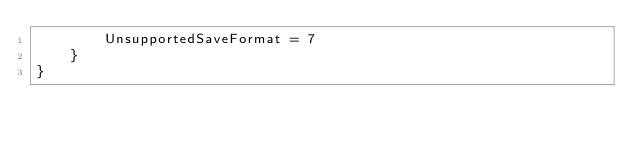Convert code to text. <code><loc_0><loc_0><loc_500><loc_500><_C#_>        UnsupportedSaveFormat = 7
    }
}</code> 